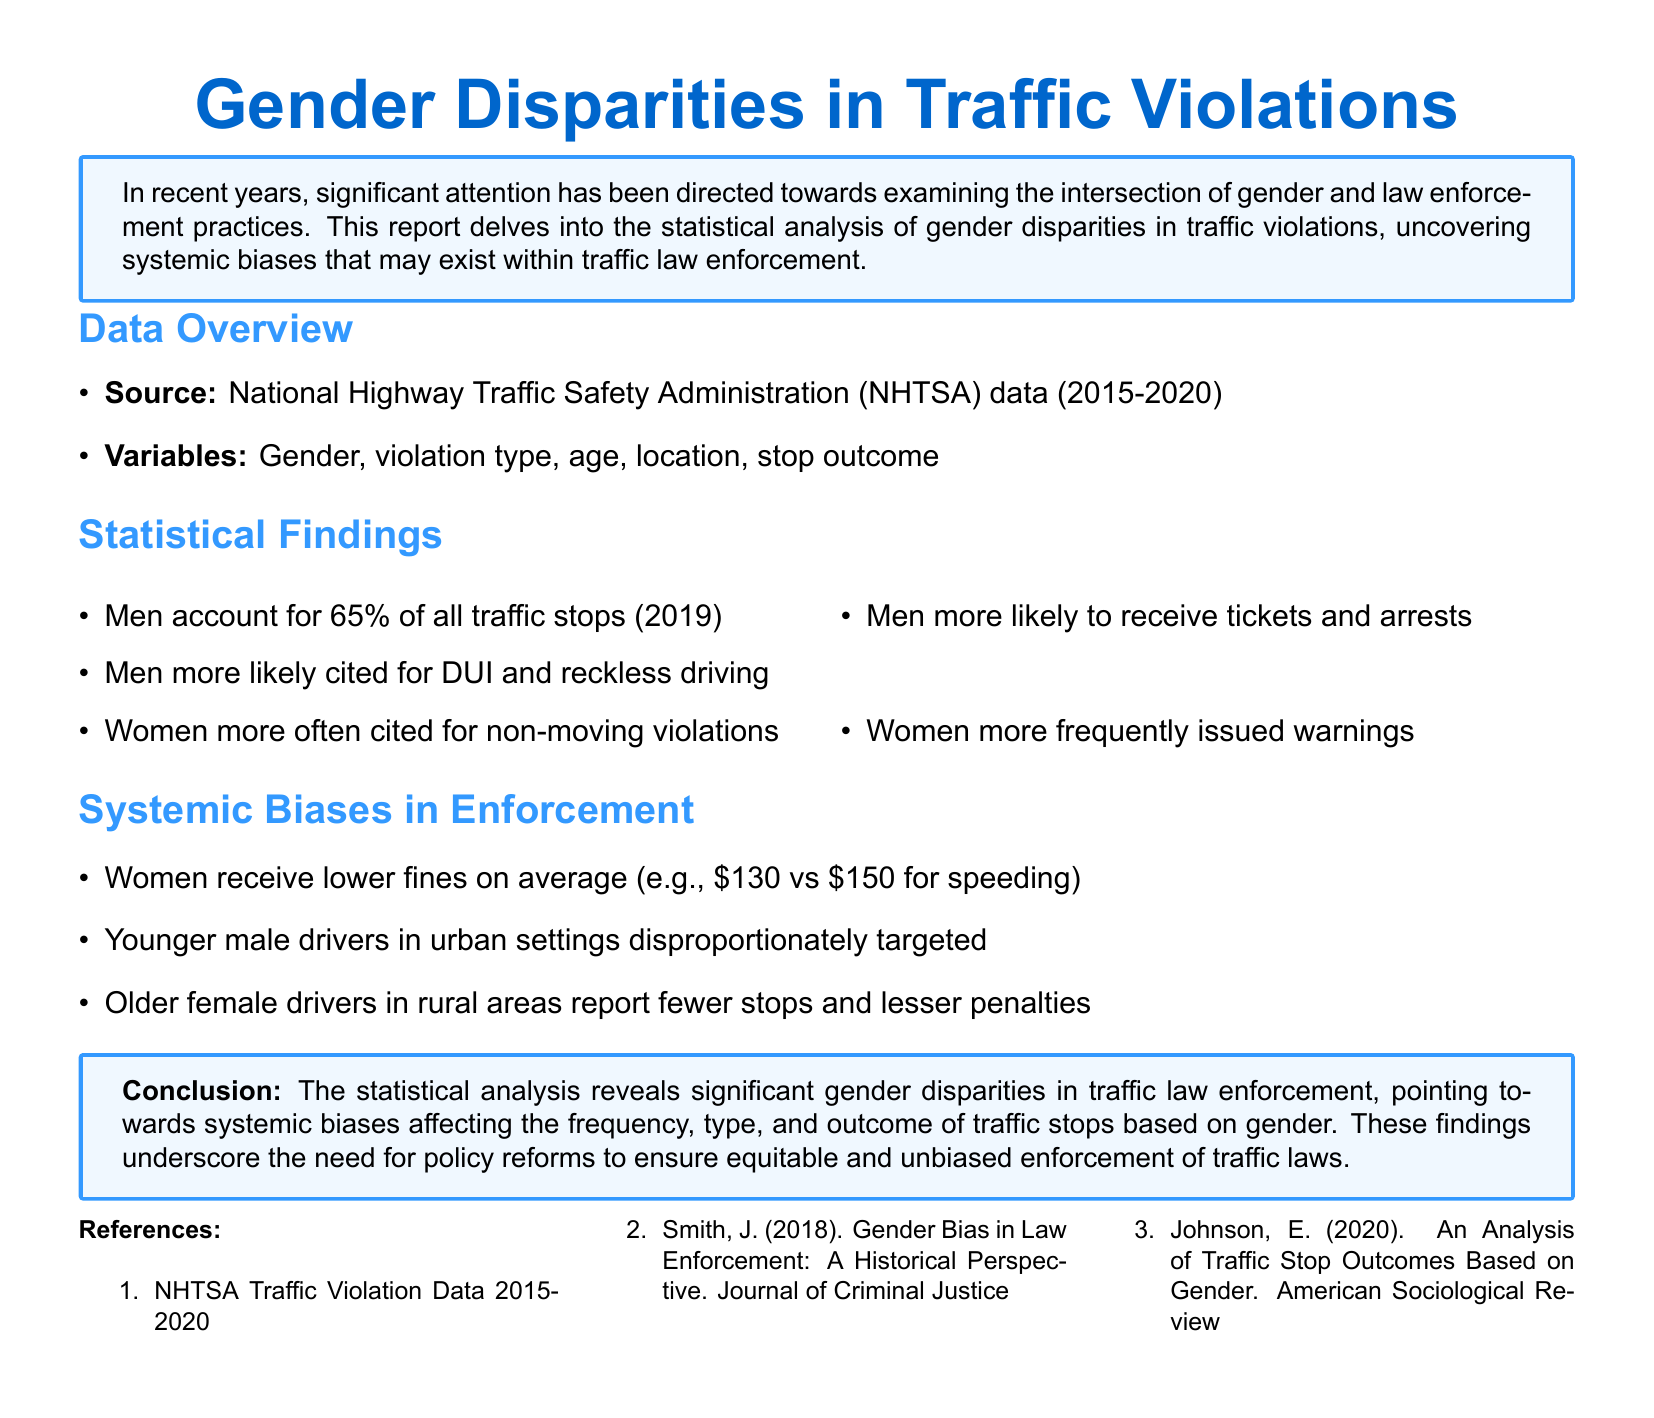What is the source of the data? The source of the data is the National Highway Traffic Safety Administration (NHTSA) from the years 2015-2020.
Answer: National Highway Traffic Safety Administration (NHTSA) What percentage of traffic stops do men account for in 2019? The document states that men account for 65% of all traffic stops in 2019.
Answer: 65% What type of violations are women more often cited for? The report mentions that women are more often cited for non-moving violations.
Answer: Non-moving violations What is the average fine for women compared to men for speeding? The document specifies that women receive an average fine of $130, while men receive an average fine of $150 for speeding.
Answer: $130 vs $150 What does the report suggest about younger male drivers? It states that younger male drivers in urban settings are disproportionately targeted by law enforcement.
Answer: Disproportionately targeted What key issue does the conclusion of the report highlight? The conclusion highlights significant gender disparities in traffic law enforcement and systemic biases affecting outcomes.
Answer: Systemic biases Which demographic reports fewer stops and lesser penalties according to the findings? Older female drivers in rural areas report fewer stops and lesser penalties.
Answer: Older female drivers Who authored the 2018 reference cited in the document? The author of the cited reference from 2018 is J. Smith.
Answer: J. Smith 